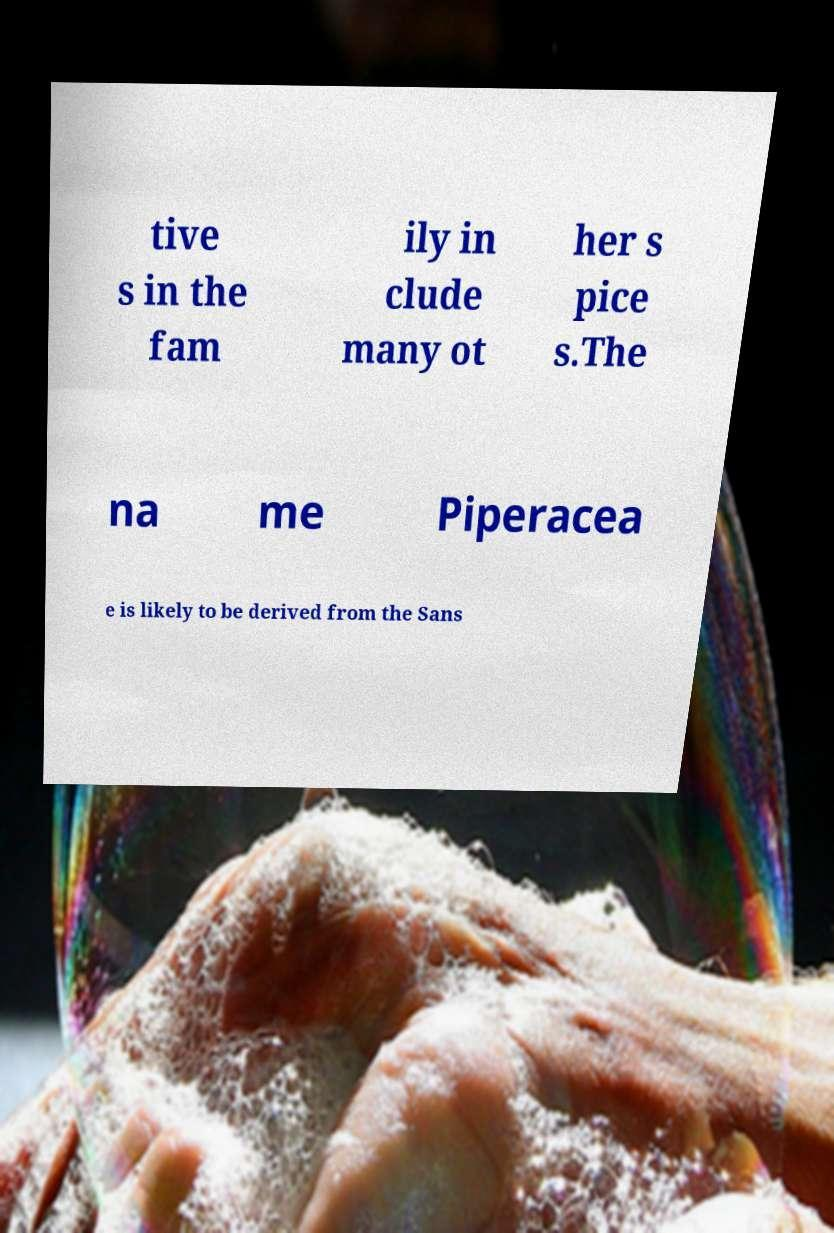For documentation purposes, I need the text within this image transcribed. Could you provide that? tive s in the fam ily in clude many ot her s pice s.The na me Piperacea e is likely to be derived from the Sans 